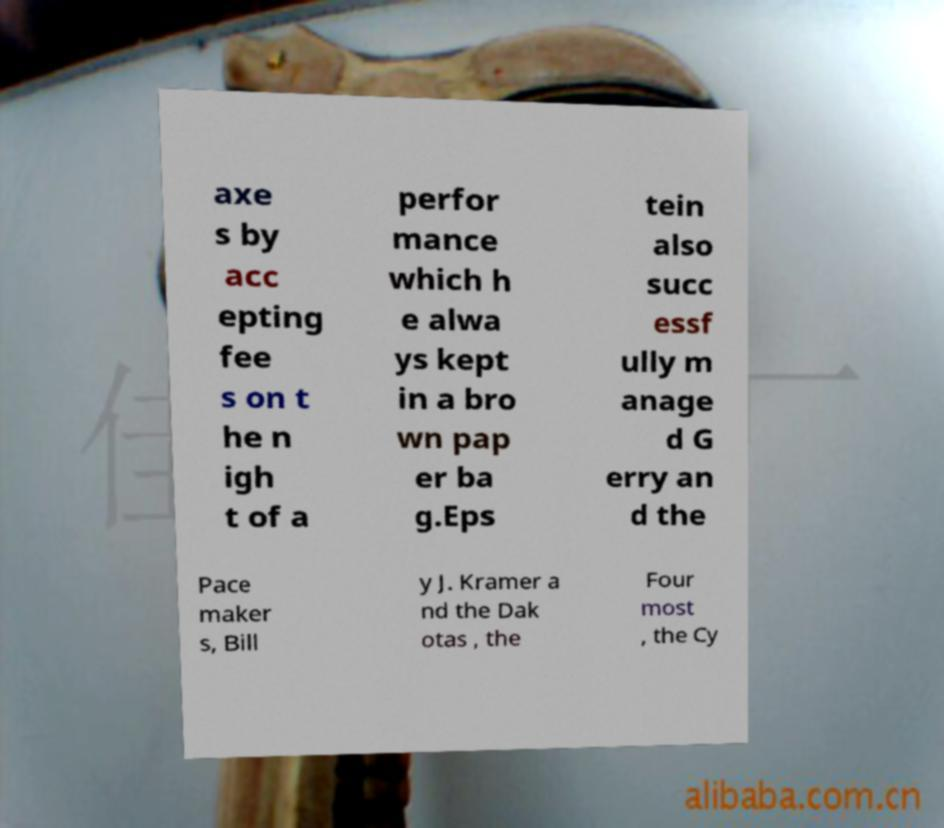Please read and relay the text visible in this image. What does it say? axe s by acc epting fee s on t he n igh t of a perfor mance which h e alwa ys kept in a bro wn pap er ba g.Eps tein also succ essf ully m anage d G erry an d the Pace maker s, Bill y J. Kramer a nd the Dak otas , the Four most , the Cy 